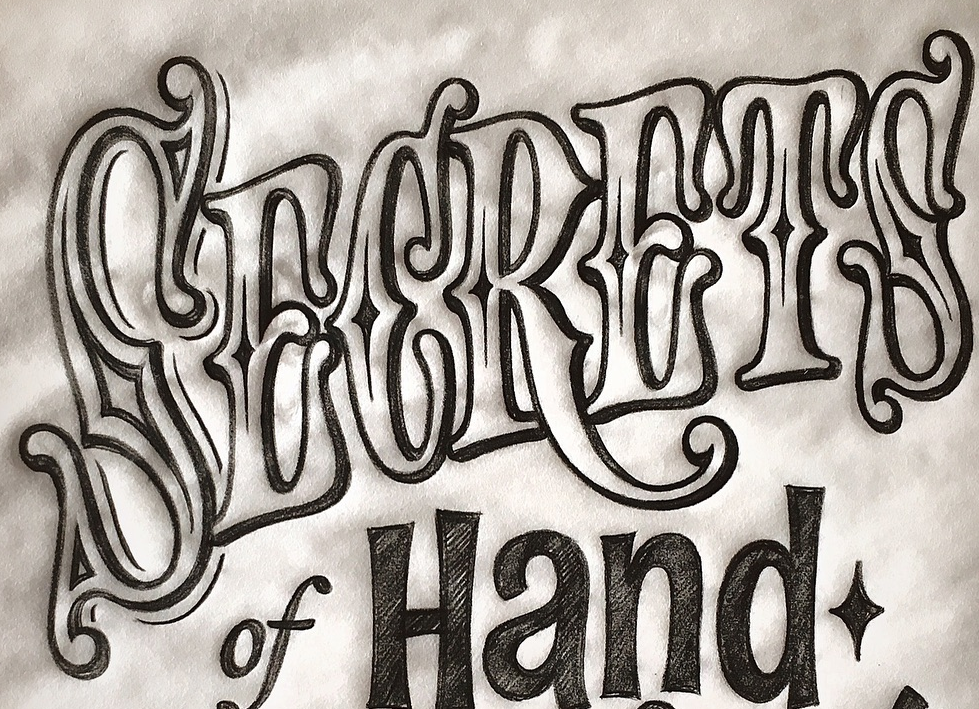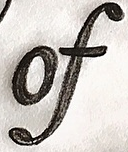What words can you see in these images in sequence, separated by a semicolon? SECRETS; of 